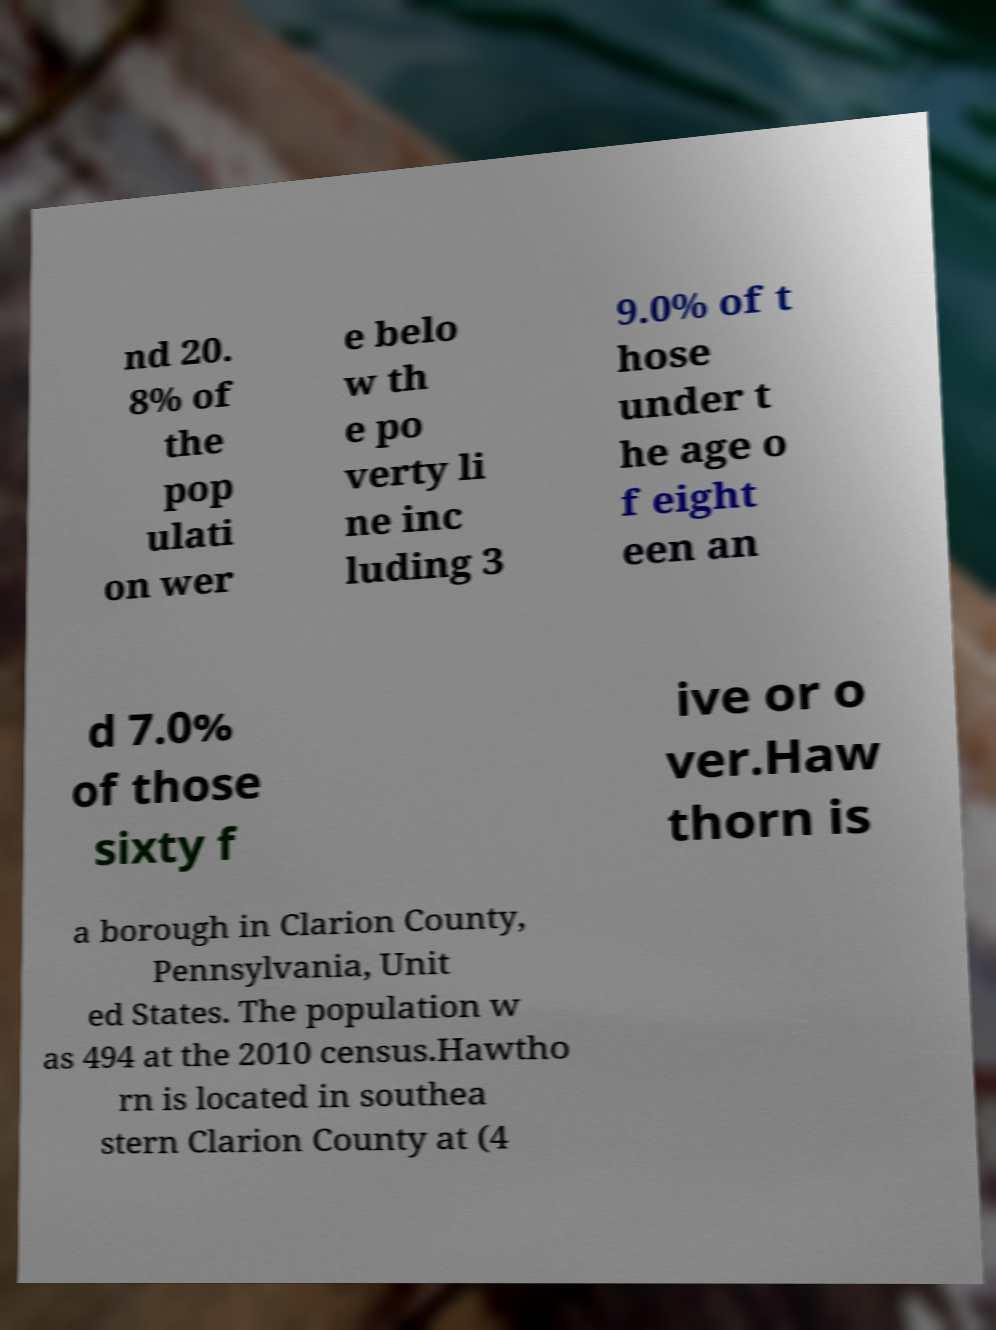What messages or text are displayed in this image? I need them in a readable, typed format. nd 20. 8% of the pop ulati on wer e belo w th e po verty li ne inc luding 3 9.0% of t hose under t he age o f eight een an d 7.0% of those sixty f ive or o ver.Haw thorn is a borough in Clarion County, Pennsylvania, Unit ed States. The population w as 494 at the 2010 census.Hawtho rn is located in southea stern Clarion County at (4 